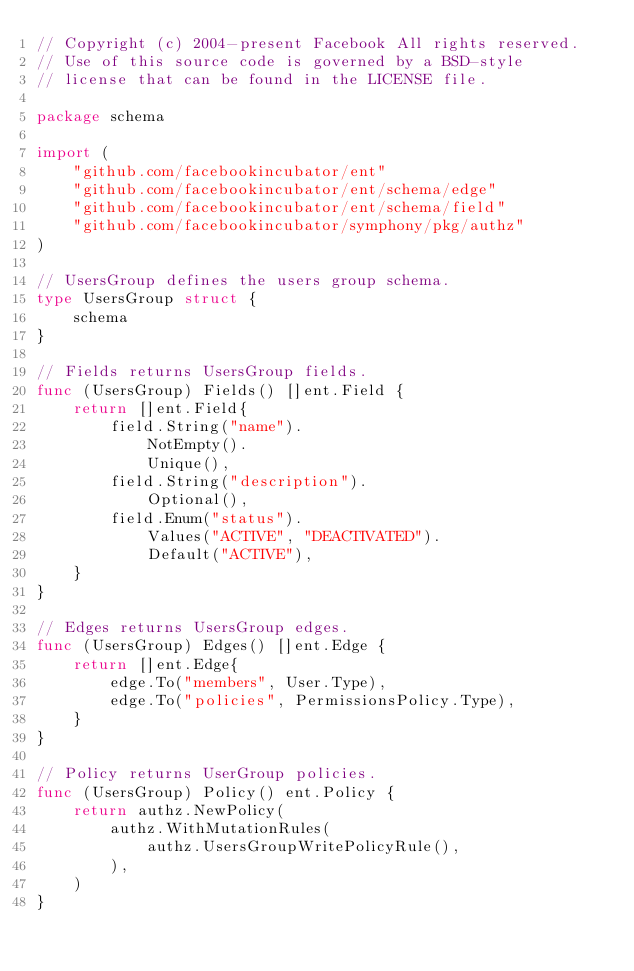Convert code to text. <code><loc_0><loc_0><loc_500><loc_500><_Go_>// Copyright (c) 2004-present Facebook All rights reserved.
// Use of this source code is governed by a BSD-style
// license that can be found in the LICENSE file.

package schema

import (
	"github.com/facebookincubator/ent"
	"github.com/facebookincubator/ent/schema/edge"
	"github.com/facebookincubator/ent/schema/field"
	"github.com/facebookincubator/symphony/pkg/authz"
)

// UsersGroup defines the users group schema.
type UsersGroup struct {
	schema
}

// Fields returns UsersGroup fields.
func (UsersGroup) Fields() []ent.Field {
	return []ent.Field{
		field.String("name").
			NotEmpty().
			Unique(),
		field.String("description").
			Optional(),
		field.Enum("status").
			Values("ACTIVE", "DEACTIVATED").
			Default("ACTIVE"),
	}
}

// Edges returns UsersGroup edges.
func (UsersGroup) Edges() []ent.Edge {
	return []ent.Edge{
		edge.To("members", User.Type),
		edge.To("policies", PermissionsPolicy.Type),
	}
}

// Policy returns UserGroup policies.
func (UsersGroup) Policy() ent.Policy {
	return authz.NewPolicy(
		authz.WithMutationRules(
			authz.UsersGroupWritePolicyRule(),
		),
	)
}
</code> 